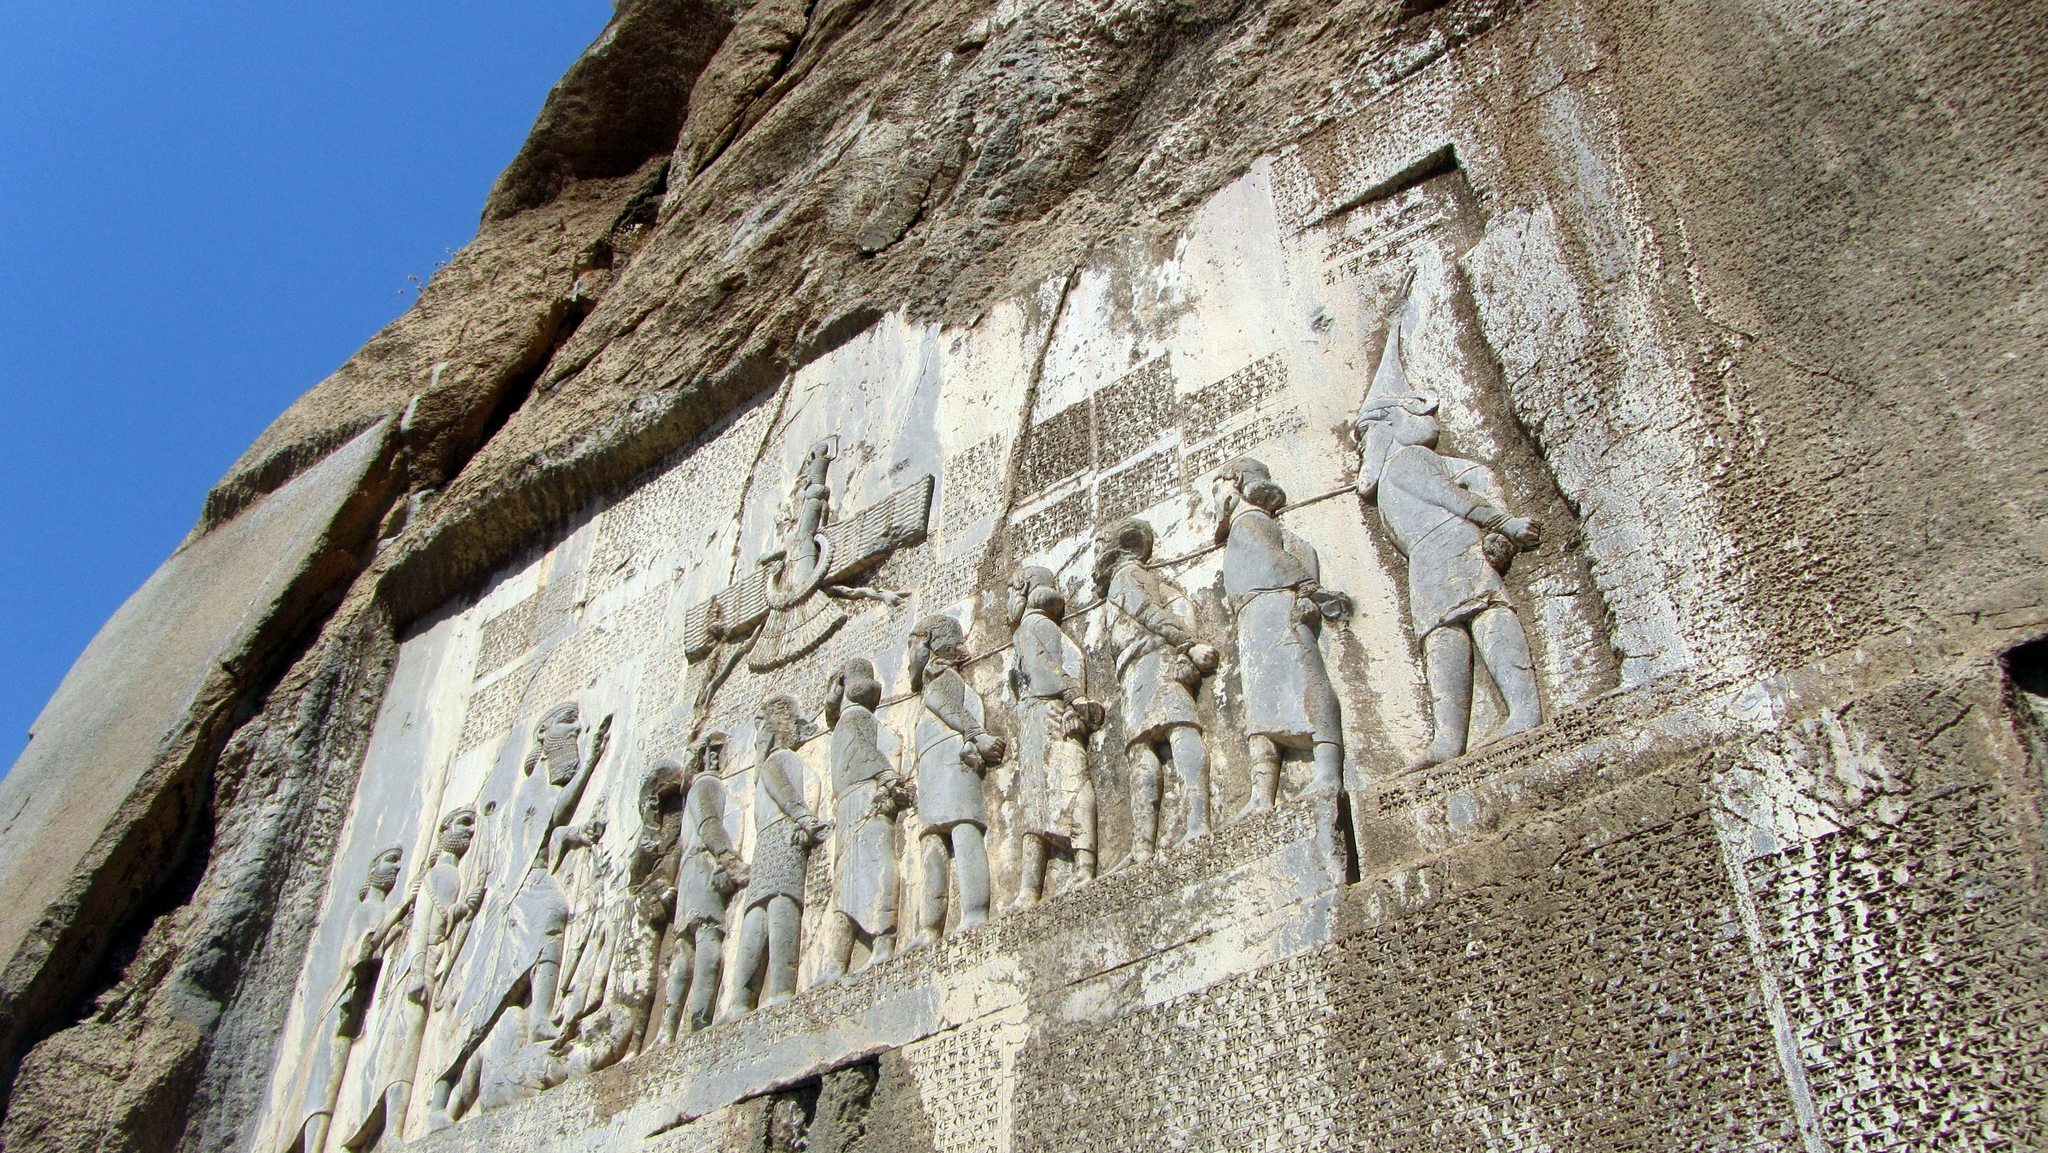Could you describe the specific figures seen in the relief? What do their poses and attire suggest about their identities? The relief features several figures, each meticulously carved to show details like clothing and posture that reflect their status and role. The prominent figure in the center, depicted larger than the others, is Darius the Great, identifiable by his regal attire and commanding posture. Surrounding him are smaller figures, likely representing defeated kings or enemies, shown in a submissive posture—bound and with heads bowed—as a symbol of their subjugation to Persian authority. The detailed depiction of clothing and weapons also serves to highlight the hierarchical nature of the scene and by extension, Persian society. 